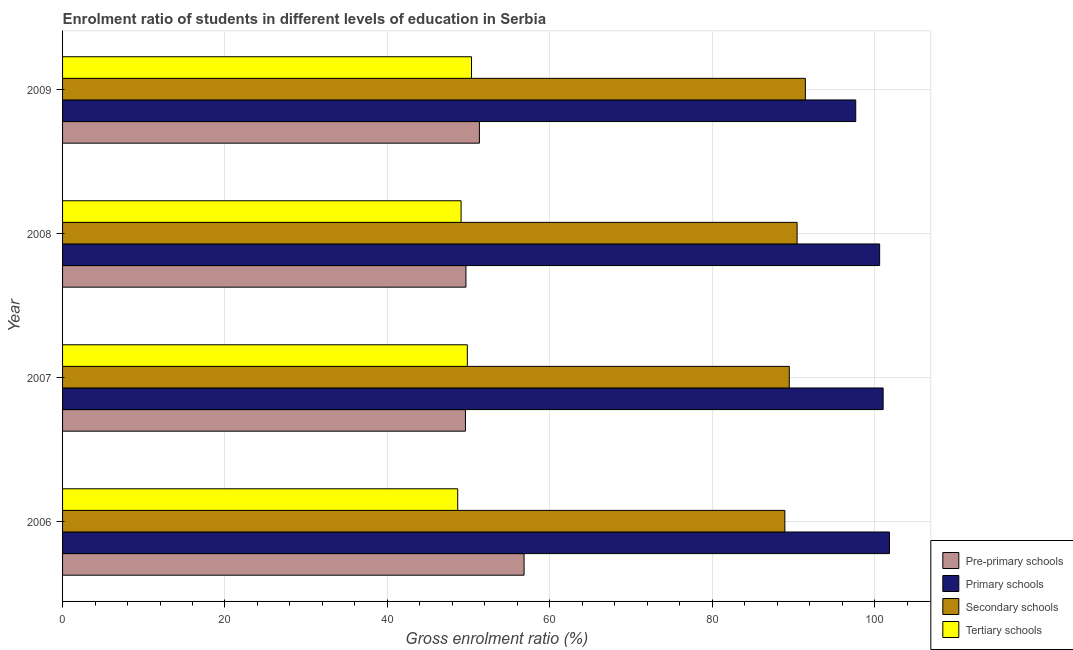How many different coloured bars are there?
Provide a succinct answer. 4. How many bars are there on the 2nd tick from the top?
Your answer should be compact. 4. How many bars are there on the 4th tick from the bottom?
Provide a succinct answer. 4. In how many cases, is the number of bars for a given year not equal to the number of legend labels?
Make the answer very short. 0. What is the gross enrolment ratio in secondary schools in 2006?
Make the answer very short. 88.96. Across all years, what is the maximum gross enrolment ratio in secondary schools?
Your answer should be compact. 91.48. Across all years, what is the minimum gross enrolment ratio in primary schools?
Provide a succinct answer. 97.69. In which year was the gross enrolment ratio in primary schools minimum?
Your answer should be very brief. 2009. What is the total gross enrolment ratio in tertiary schools in the graph?
Your answer should be very brief. 197.96. What is the difference between the gross enrolment ratio in primary schools in 2006 and that in 2008?
Keep it short and to the point. 1.21. What is the difference between the gross enrolment ratio in pre-primary schools in 2006 and the gross enrolment ratio in tertiary schools in 2008?
Provide a short and direct response. 7.76. What is the average gross enrolment ratio in primary schools per year?
Your answer should be very brief. 100.3. In the year 2006, what is the difference between the gross enrolment ratio in primary schools and gross enrolment ratio in secondary schools?
Give a very brief answer. 12.88. Is the difference between the gross enrolment ratio in secondary schools in 2008 and 2009 greater than the difference between the gross enrolment ratio in tertiary schools in 2008 and 2009?
Provide a succinct answer. Yes. What is the difference between the highest and the second highest gross enrolment ratio in pre-primary schools?
Offer a very short reply. 5.5. What is the difference between the highest and the lowest gross enrolment ratio in primary schools?
Give a very brief answer. 4.15. In how many years, is the gross enrolment ratio in secondary schools greater than the average gross enrolment ratio in secondary schools taken over all years?
Keep it short and to the point. 2. What does the 4th bar from the top in 2008 represents?
Provide a short and direct response. Pre-primary schools. What does the 2nd bar from the bottom in 2009 represents?
Your response must be concise. Primary schools. How many bars are there?
Keep it short and to the point. 16. Are all the bars in the graph horizontal?
Offer a very short reply. Yes. Are the values on the major ticks of X-axis written in scientific E-notation?
Offer a terse response. No. Does the graph contain any zero values?
Provide a short and direct response. No. Does the graph contain grids?
Offer a terse response. Yes. What is the title of the graph?
Your response must be concise. Enrolment ratio of students in different levels of education in Serbia. What is the label or title of the X-axis?
Provide a short and direct response. Gross enrolment ratio (%). What is the Gross enrolment ratio (%) of Pre-primary schools in 2006?
Provide a short and direct response. 56.84. What is the Gross enrolment ratio (%) in Primary schools in 2006?
Offer a very short reply. 101.84. What is the Gross enrolment ratio (%) in Secondary schools in 2006?
Your response must be concise. 88.96. What is the Gross enrolment ratio (%) of Tertiary schools in 2006?
Offer a terse response. 48.67. What is the Gross enrolment ratio (%) of Pre-primary schools in 2007?
Ensure brevity in your answer.  49.62. What is the Gross enrolment ratio (%) in Primary schools in 2007?
Make the answer very short. 101.06. What is the Gross enrolment ratio (%) in Secondary schools in 2007?
Keep it short and to the point. 89.5. What is the Gross enrolment ratio (%) of Tertiary schools in 2007?
Your answer should be very brief. 49.85. What is the Gross enrolment ratio (%) in Pre-primary schools in 2008?
Your answer should be compact. 49.68. What is the Gross enrolment ratio (%) of Primary schools in 2008?
Your answer should be compact. 100.63. What is the Gross enrolment ratio (%) in Secondary schools in 2008?
Ensure brevity in your answer.  90.46. What is the Gross enrolment ratio (%) in Tertiary schools in 2008?
Your answer should be very brief. 49.08. What is the Gross enrolment ratio (%) of Pre-primary schools in 2009?
Your answer should be very brief. 51.34. What is the Gross enrolment ratio (%) in Primary schools in 2009?
Your answer should be very brief. 97.69. What is the Gross enrolment ratio (%) in Secondary schools in 2009?
Your answer should be compact. 91.48. What is the Gross enrolment ratio (%) of Tertiary schools in 2009?
Offer a very short reply. 50.37. Across all years, what is the maximum Gross enrolment ratio (%) of Pre-primary schools?
Ensure brevity in your answer.  56.84. Across all years, what is the maximum Gross enrolment ratio (%) of Primary schools?
Provide a short and direct response. 101.84. Across all years, what is the maximum Gross enrolment ratio (%) in Secondary schools?
Provide a succinct answer. 91.48. Across all years, what is the maximum Gross enrolment ratio (%) in Tertiary schools?
Your answer should be very brief. 50.37. Across all years, what is the minimum Gross enrolment ratio (%) of Pre-primary schools?
Keep it short and to the point. 49.62. Across all years, what is the minimum Gross enrolment ratio (%) of Primary schools?
Ensure brevity in your answer.  97.69. Across all years, what is the minimum Gross enrolment ratio (%) of Secondary schools?
Give a very brief answer. 88.96. Across all years, what is the minimum Gross enrolment ratio (%) of Tertiary schools?
Keep it short and to the point. 48.67. What is the total Gross enrolment ratio (%) of Pre-primary schools in the graph?
Give a very brief answer. 207.48. What is the total Gross enrolment ratio (%) in Primary schools in the graph?
Make the answer very short. 401.22. What is the total Gross enrolment ratio (%) in Secondary schools in the graph?
Give a very brief answer. 360.41. What is the total Gross enrolment ratio (%) of Tertiary schools in the graph?
Provide a succinct answer. 197.96. What is the difference between the Gross enrolment ratio (%) in Pre-primary schools in 2006 and that in 2007?
Offer a terse response. 7.22. What is the difference between the Gross enrolment ratio (%) of Primary schools in 2006 and that in 2007?
Your response must be concise. 0.78. What is the difference between the Gross enrolment ratio (%) in Secondary schools in 2006 and that in 2007?
Your response must be concise. -0.54. What is the difference between the Gross enrolment ratio (%) in Tertiary schools in 2006 and that in 2007?
Give a very brief answer. -1.18. What is the difference between the Gross enrolment ratio (%) in Pre-primary schools in 2006 and that in 2008?
Provide a short and direct response. 7.16. What is the difference between the Gross enrolment ratio (%) in Primary schools in 2006 and that in 2008?
Keep it short and to the point. 1.21. What is the difference between the Gross enrolment ratio (%) of Secondary schools in 2006 and that in 2008?
Your answer should be compact. -1.51. What is the difference between the Gross enrolment ratio (%) in Tertiary schools in 2006 and that in 2008?
Make the answer very short. -0.42. What is the difference between the Gross enrolment ratio (%) in Pre-primary schools in 2006 and that in 2009?
Make the answer very short. 5.5. What is the difference between the Gross enrolment ratio (%) in Primary schools in 2006 and that in 2009?
Give a very brief answer. 4.15. What is the difference between the Gross enrolment ratio (%) of Secondary schools in 2006 and that in 2009?
Make the answer very short. -2.53. What is the difference between the Gross enrolment ratio (%) of Tertiary schools in 2006 and that in 2009?
Give a very brief answer. -1.7. What is the difference between the Gross enrolment ratio (%) in Pre-primary schools in 2007 and that in 2008?
Provide a short and direct response. -0.06. What is the difference between the Gross enrolment ratio (%) in Primary schools in 2007 and that in 2008?
Ensure brevity in your answer.  0.43. What is the difference between the Gross enrolment ratio (%) in Secondary schools in 2007 and that in 2008?
Keep it short and to the point. -0.96. What is the difference between the Gross enrolment ratio (%) of Tertiary schools in 2007 and that in 2008?
Provide a short and direct response. 0.77. What is the difference between the Gross enrolment ratio (%) in Pre-primary schools in 2007 and that in 2009?
Your response must be concise. -1.72. What is the difference between the Gross enrolment ratio (%) of Primary schools in 2007 and that in 2009?
Ensure brevity in your answer.  3.38. What is the difference between the Gross enrolment ratio (%) of Secondary schools in 2007 and that in 2009?
Provide a succinct answer. -1.98. What is the difference between the Gross enrolment ratio (%) of Tertiary schools in 2007 and that in 2009?
Give a very brief answer. -0.52. What is the difference between the Gross enrolment ratio (%) in Pre-primary schools in 2008 and that in 2009?
Provide a succinct answer. -1.66. What is the difference between the Gross enrolment ratio (%) in Primary schools in 2008 and that in 2009?
Your answer should be very brief. 2.94. What is the difference between the Gross enrolment ratio (%) of Secondary schools in 2008 and that in 2009?
Your answer should be very brief. -1.02. What is the difference between the Gross enrolment ratio (%) in Tertiary schools in 2008 and that in 2009?
Your answer should be compact. -1.28. What is the difference between the Gross enrolment ratio (%) of Pre-primary schools in 2006 and the Gross enrolment ratio (%) of Primary schools in 2007?
Ensure brevity in your answer.  -44.22. What is the difference between the Gross enrolment ratio (%) in Pre-primary schools in 2006 and the Gross enrolment ratio (%) in Secondary schools in 2007?
Provide a short and direct response. -32.66. What is the difference between the Gross enrolment ratio (%) in Pre-primary schools in 2006 and the Gross enrolment ratio (%) in Tertiary schools in 2007?
Offer a terse response. 6.99. What is the difference between the Gross enrolment ratio (%) in Primary schools in 2006 and the Gross enrolment ratio (%) in Secondary schools in 2007?
Provide a short and direct response. 12.34. What is the difference between the Gross enrolment ratio (%) in Primary schools in 2006 and the Gross enrolment ratio (%) in Tertiary schools in 2007?
Give a very brief answer. 51.99. What is the difference between the Gross enrolment ratio (%) of Secondary schools in 2006 and the Gross enrolment ratio (%) of Tertiary schools in 2007?
Make the answer very short. 39.11. What is the difference between the Gross enrolment ratio (%) of Pre-primary schools in 2006 and the Gross enrolment ratio (%) of Primary schools in 2008?
Make the answer very short. -43.79. What is the difference between the Gross enrolment ratio (%) of Pre-primary schools in 2006 and the Gross enrolment ratio (%) of Secondary schools in 2008?
Your response must be concise. -33.62. What is the difference between the Gross enrolment ratio (%) of Pre-primary schools in 2006 and the Gross enrolment ratio (%) of Tertiary schools in 2008?
Make the answer very short. 7.76. What is the difference between the Gross enrolment ratio (%) of Primary schools in 2006 and the Gross enrolment ratio (%) of Secondary schools in 2008?
Make the answer very short. 11.38. What is the difference between the Gross enrolment ratio (%) of Primary schools in 2006 and the Gross enrolment ratio (%) of Tertiary schools in 2008?
Your answer should be compact. 52.76. What is the difference between the Gross enrolment ratio (%) in Secondary schools in 2006 and the Gross enrolment ratio (%) in Tertiary schools in 2008?
Offer a terse response. 39.87. What is the difference between the Gross enrolment ratio (%) of Pre-primary schools in 2006 and the Gross enrolment ratio (%) of Primary schools in 2009?
Your response must be concise. -40.85. What is the difference between the Gross enrolment ratio (%) of Pre-primary schools in 2006 and the Gross enrolment ratio (%) of Secondary schools in 2009?
Offer a terse response. -34.64. What is the difference between the Gross enrolment ratio (%) in Pre-primary schools in 2006 and the Gross enrolment ratio (%) in Tertiary schools in 2009?
Provide a succinct answer. 6.48. What is the difference between the Gross enrolment ratio (%) in Primary schools in 2006 and the Gross enrolment ratio (%) in Secondary schools in 2009?
Provide a succinct answer. 10.36. What is the difference between the Gross enrolment ratio (%) of Primary schools in 2006 and the Gross enrolment ratio (%) of Tertiary schools in 2009?
Your answer should be compact. 51.47. What is the difference between the Gross enrolment ratio (%) in Secondary schools in 2006 and the Gross enrolment ratio (%) in Tertiary schools in 2009?
Keep it short and to the point. 38.59. What is the difference between the Gross enrolment ratio (%) in Pre-primary schools in 2007 and the Gross enrolment ratio (%) in Primary schools in 2008?
Provide a succinct answer. -51.01. What is the difference between the Gross enrolment ratio (%) of Pre-primary schools in 2007 and the Gross enrolment ratio (%) of Secondary schools in 2008?
Offer a terse response. -40.84. What is the difference between the Gross enrolment ratio (%) in Pre-primary schools in 2007 and the Gross enrolment ratio (%) in Tertiary schools in 2008?
Your response must be concise. 0.54. What is the difference between the Gross enrolment ratio (%) of Primary schools in 2007 and the Gross enrolment ratio (%) of Secondary schools in 2008?
Make the answer very short. 10.6. What is the difference between the Gross enrolment ratio (%) of Primary schools in 2007 and the Gross enrolment ratio (%) of Tertiary schools in 2008?
Make the answer very short. 51.98. What is the difference between the Gross enrolment ratio (%) in Secondary schools in 2007 and the Gross enrolment ratio (%) in Tertiary schools in 2008?
Your answer should be compact. 40.42. What is the difference between the Gross enrolment ratio (%) in Pre-primary schools in 2007 and the Gross enrolment ratio (%) in Primary schools in 2009?
Make the answer very short. -48.07. What is the difference between the Gross enrolment ratio (%) of Pre-primary schools in 2007 and the Gross enrolment ratio (%) of Secondary schools in 2009?
Keep it short and to the point. -41.86. What is the difference between the Gross enrolment ratio (%) in Pre-primary schools in 2007 and the Gross enrolment ratio (%) in Tertiary schools in 2009?
Offer a terse response. -0.75. What is the difference between the Gross enrolment ratio (%) in Primary schools in 2007 and the Gross enrolment ratio (%) in Secondary schools in 2009?
Your response must be concise. 9.58. What is the difference between the Gross enrolment ratio (%) of Primary schools in 2007 and the Gross enrolment ratio (%) of Tertiary schools in 2009?
Provide a short and direct response. 50.7. What is the difference between the Gross enrolment ratio (%) of Secondary schools in 2007 and the Gross enrolment ratio (%) of Tertiary schools in 2009?
Make the answer very short. 39.14. What is the difference between the Gross enrolment ratio (%) of Pre-primary schools in 2008 and the Gross enrolment ratio (%) of Primary schools in 2009?
Make the answer very short. -48. What is the difference between the Gross enrolment ratio (%) in Pre-primary schools in 2008 and the Gross enrolment ratio (%) in Secondary schools in 2009?
Make the answer very short. -41.8. What is the difference between the Gross enrolment ratio (%) in Pre-primary schools in 2008 and the Gross enrolment ratio (%) in Tertiary schools in 2009?
Your answer should be very brief. -0.68. What is the difference between the Gross enrolment ratio (%) in Primary schools in 2008 and the Gross enrolment ratio (%) in Secondary schools in 2009?
Offer a terse response. 9.15. What is the difference between the Gross enrolment ratio (%) in Primary schools in 2008 and the Gross enrolment ratio (%) in Tertiary schools in 2009?
Offer a terse response. 50.26. What is the difference between the Gross enrolment ratio (%) of Secondary schools in 2008 and the Gross enrolment ratio (%) of Tertiary schools in 2009?
Make the answer very short. 40.1. What is the average Gross enrolment ratio (%) in Pre-primary schools per year?
Offer a very short reply. 51.87. What is the average Gross enrolment ratio (%) in Primary schools per year?
Ensure brevity in your answer.  100.3. What is the average Gross enrolment ratio (%) in Secondary schools per year?
Provide a short and direct response. 90.1. What is the average Gross enrolment ratio (%) of Tertiary schools per year?
Make the answer very short. 49.49. In the year 2006, what is the difference between the Gross enrolment ratio (%) of Pre-primary schools and Gross enrolment ratio (%) of Primary schools?
Provide a succinct answer. -45. In the year 2006, what is the difference between the Gross enrolment ratio (%) of Pre-primary schools and Gross enrolment ratio (%) of Secondary schools?
Your response must be concise. -32.12. In the year 2006, what is the difference between the Gross enrolment ratio (%) of Pre-primary schools and Gross enrolment ratio (%) of Tertiary schools?
Ensure brevity in your answer.  8.18. In the year 2006, what is the difference between the Gross enrolment ratio (%) of Primary schools and Gross enrolment ratio (%) of Secondary schools?
Keep it short and to the point. 12.88. In the year 2006, what is the difference between the Gross enrolment ratio (%) in Primary schools and Gross enrolment ratio (%) in Tertiary schools?
Keep it short and to the point. 53.17. In the year 2006, what is the difference between the Gross enrolment ratio (%) in Secondary schools and Gross enrolment ratio (%) in Tertiary schools?
Provide a succinct answer. 40.29. In the year 2007, what is the difference between the Gross enrolment ratio (%) of Pre-primary schools and Gross enrolment ratio (%) of Primary schools?
Give a very brief answer. -51.44. In the year 2007, what is the difference between the Gross enrolment ratio (%) in Pre-primary schools and Gross enrolment ratio (%) in Secondary schools?
Ensure brevity in your answer.  -39.88. In the year 2007, what is the difference between the Gross enrolment ratio (%) of Pre-primary schools and Gross enrolment ratio (%) of Tertiary schools?
Your response must be concise. -0.23. In the year 2007, what is the difference between the Gross enrolment ratio (%) in Primary schools and Gross enrolment ratio (%) in Secondary schools?
Ensure brevity in your answer.  11.56. In the year 2007, what is the difference between the Gross enrolment ratio (%) in Primary schools and Gross enrolment ratio (%) in Tertiary schools?
Your answer should be compact. 51.21. In the year 2007, what is the difference between the Gross enrolment ratio (%) in Secondary schools and Gross enrolment ratio (%) in Tertiary schools?
Ensure brevity in your answer.  39.65. In the year 2008, what is the difference between the Gross enrolment ratio (%) of Pre-primary schools and Gross enrolment ratio (%) of Primary schools?
Provide a succinct answer. -50.95. In the year 2008, what is the difference between the Gross enrolment ratio (%) of Pre-primary schools and Gross enrolment ratio (%) of Secondary schools?
Ensure brevity in your answer.  -40.78. In the year 2008, what is the difference between the Gross enrolment ratio (%) in Pre-primary schools and Gross enrolment ratio (%) in Tertiary schools?
Give a very brief answer. 0.6. In the year 2008, what is the difference between the Gross enrolment ratio (%) in Primary schools and Gross enrolment ratio (%) in Secondary schools?
Your answer should be very brief. 10.17. In the year 2008, what is the difference between the Gross enrolment ratio (%) in Primary schools and Gross enrolment ratio (%) in Tertiary schools?
Your answer should be very brief. 51.55. In the year 2008, what is the difference between the Gross enrolment ratio (%) of Secondary schools and Gross enrolment ratio (%) of Tertiary schools?
Make the answer very short. 41.38. In the year 2009, what is the difference between the Gross enrolment ratio (%) in Pre-primary schools and Gross enrolment ratio (%) in Primary schools?
Your answer should be compact. -46.35. In the year 2009, what is the difference between the Gross enrolment ratio (%) of Pre-primary schools and Gross enrolment ratio (%) of Secondary schools?
Offer a very short reply. -40.15. In the year 2009, what is the difference between the Gross enrolment ratio (%) of Pre-primary schools and Gross enrolment ratio (%) of Tertiary schools?
Keep it short and to the point. 0.97. In the year 2009, what is the difference between the Gross enrolment ratio (%) in Primary schools and Gross enrolment ratio (%) in Secondary schools?
Your response must be concise. 6.2. In the year 2009, what is the difference between the Gross enrolment ratio (%) of Primary schools and Gross enrolment ratio (%) of Tertiary schools?
Your answer should be compact. 47.32. In the year 2009, what is the difference between the Gross enrolment ratio (%) in Secondary schools and Gross enrolment ratio (%) in Tertiary schools?
Offer a very short reply. 41.12. What is the ratio of the Gross enrolment ratio (%) in Pre-primary schools in 2006 to that in 2007?
Your answer should be very brief. 1.15. What is the ratio of the Gross enrolment ratio (%) in Primary schools in 2006 to that in 2007?
Provide a succinct answer. 1.01. What is the ratio of the Gross enrolment ratio (%) in Tertiary schools in 2006 to that in 2007?
Your answer should be compact. 0.98. What is the ratio of the Gross enrolment ratio (%) in Pre-primary schools in 2006 to that in 2008?
Provide a short and direct response. 1.14. What is the ratio of the Gross enrolment ratio (%) in Primary schools in 2006 to that in 2008?
Your response must be concise. 1.01. What is the ratio of the Gross enrolment ratio (%) of Secondary schools in 2006 to that in 2008?
Ensure brevity in your answer.  0.98. What is the ratio of the Gross enrolment ratio (%) in Pre-primary schools in 2006 to that in 2009?
Keep it short and to the point. 1.11. What is the ratio of the Gross enrolment ratio (%) of Primary schools in 2006 to that in 2009?
Ensure brevity in your answer.  1.04. What is the ratio of the Gross enrolment ratio (%) in Secondary schools in 2006 to that in 2009?
Keep it short and to the point. 0.97. What is the ratio of the Gross enrolment ratio (%) of Tertiary schools in 2006 to that in 2009?
Provide a succinct answer. 0.97. What is the ratio of the Gross enrolment ratio (%) of Pre-primary schools in 2007 to that in 2008?
Provide a succinct answer. 1. What is the ratio of the Gross enrolment ratio (%) of Secondary schools in 2007 to that in 2008?
Make the answer very short. 0.99. What is the ratio of the Gross enrolment ratio (%) of Tertiary schools in 2007 to that in 2008?
Make the answer very short. 1.02. What is the ratio of the Gross enrolment ratio (%) in Pre-primary schools in 2007 to that in 2009?
Make the answer very short. 0.97. What is the ratio of the Gross enrolment ratio (%) in Primary schools in 2007 to that in 2009?
Keep it short and to the point. 1.03. What is the ratio of the Gross enrolment ratio (%) of Secondary schools in 2007 to that in 2009?
Your response must be concise. 0.98. What is the ratio of the Gross enrolment ratio (%) of Tertiary schools in 2007 to that in 2009?
Make the answer very short. 0.99. What is the ratio of the Gross enrolment ratio (%) in Pre-primary schools in 2008 to that in 2009?
Keep it short and to the point. 0.97. What is the ratio of the Gross enrolment ratio (%) in Primary schools in 2008 to that in 2009?
Your answer should be very brief. 1.03. What is the ratio of the Gross enrolment ratio (%) of Tertiary schools in 2008 to that in 2009?
Your answer should be compact. 0.97. What is the difference between the highest and the second highest Gross enrolment ratio (%) of Pre-primary schools?
Ensure brevity in your answer.  5.5. What is the difference between the highest and the second highest Gross enrolment ratio (%) of Primary schools?
Your answer should be very brief. 0.78. What is the difference between the highest and the second highest Gross enrolment ratio (%) in Secondary schools?
Give a very brief answer. 1.02. What is the difference between the highest and the second highest Gross enrolment ratio (%) in Tertiary schools?
Provide a succinct answer. 0.52. What is the difference between the highest and the lowest Gross enrolment ratio (%) of Pre-primary schools?
Keep it short and to the point. 7.22. What is the difference between the highest and the lowest Gross enrolment ratio (%) of Primary schools?
Offer a terse response. 4.15. What is the difference between the highest and the lowest Gross enrolment ratio (%) of Secondary schools?
Provide a short and direct response. 2.53. What is the difference between the highest and the lowest Gross enrolment ratio (%) in Tertiary schools?
Offer a very short reply. 1.7. 